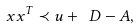<formula> <loc_0><loc_0><loc_500><loc_500>x x ^ { T } \prec u + \ D - A ,</formula> 